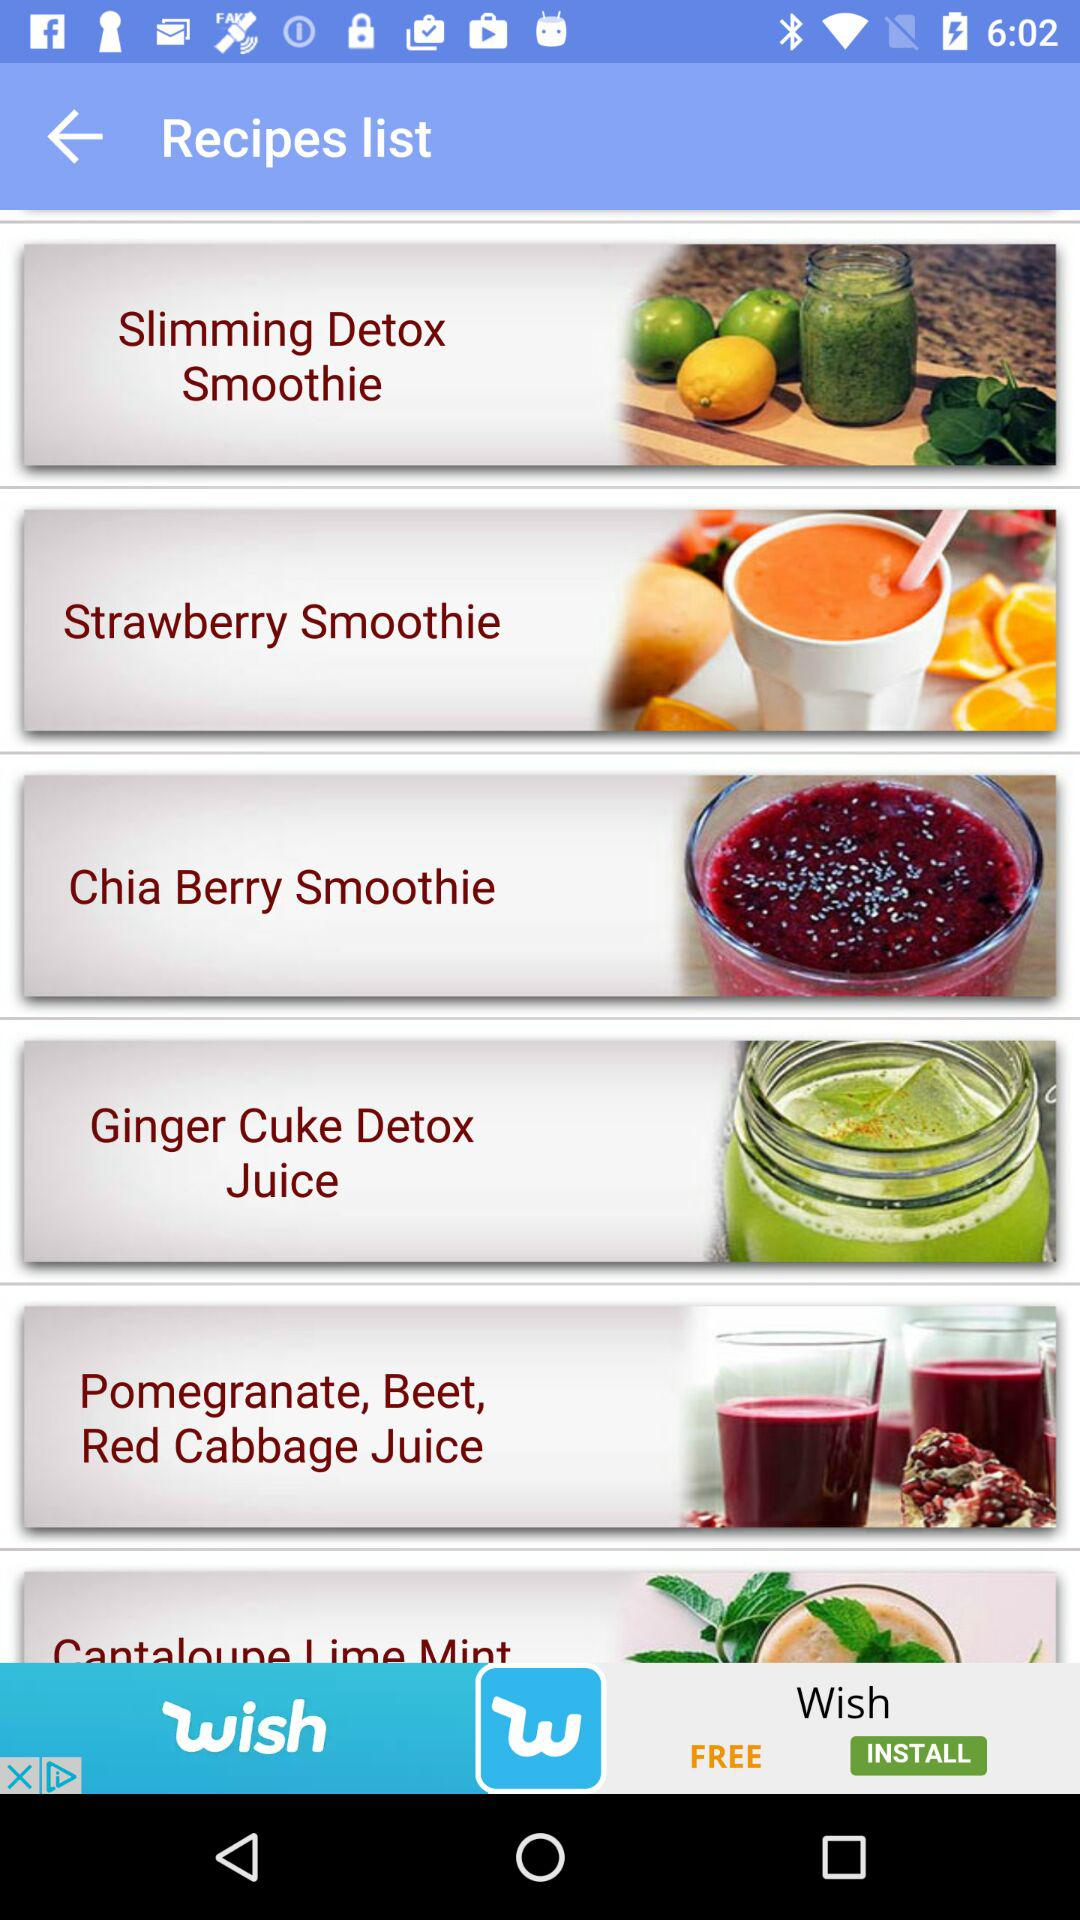How many smoothie recipes are there?
Answer the question using a single word or phrase. 6 